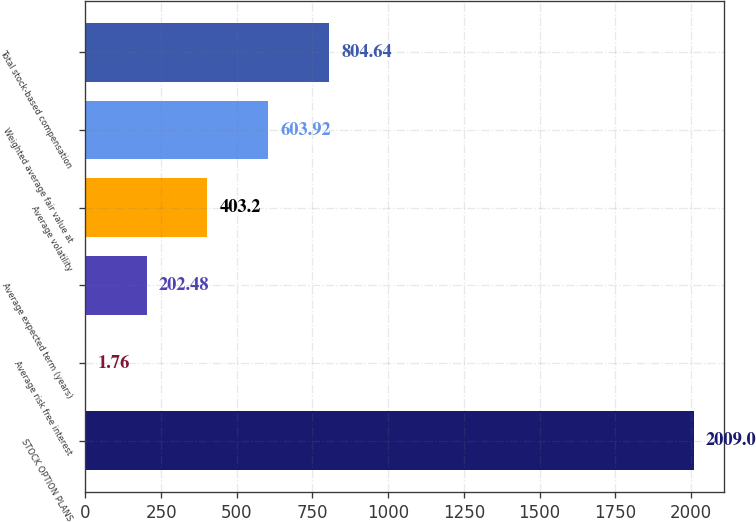<chart> <loc_0><loc_0><loc_500><loc_500><bar_chart><fcel>STOCK OPTION PLANS<fcel>Average risk free interest<fcel>Average expected term (years)<fcel>Average volatility<fcel>Weighted average fair value at<fcel>Total stock-based compensation<nl><fcel>2009<fcel>1.76<fcel>202.48<fcel>403.2<fcel>603.92<fcel>804.64<nl></chart> 